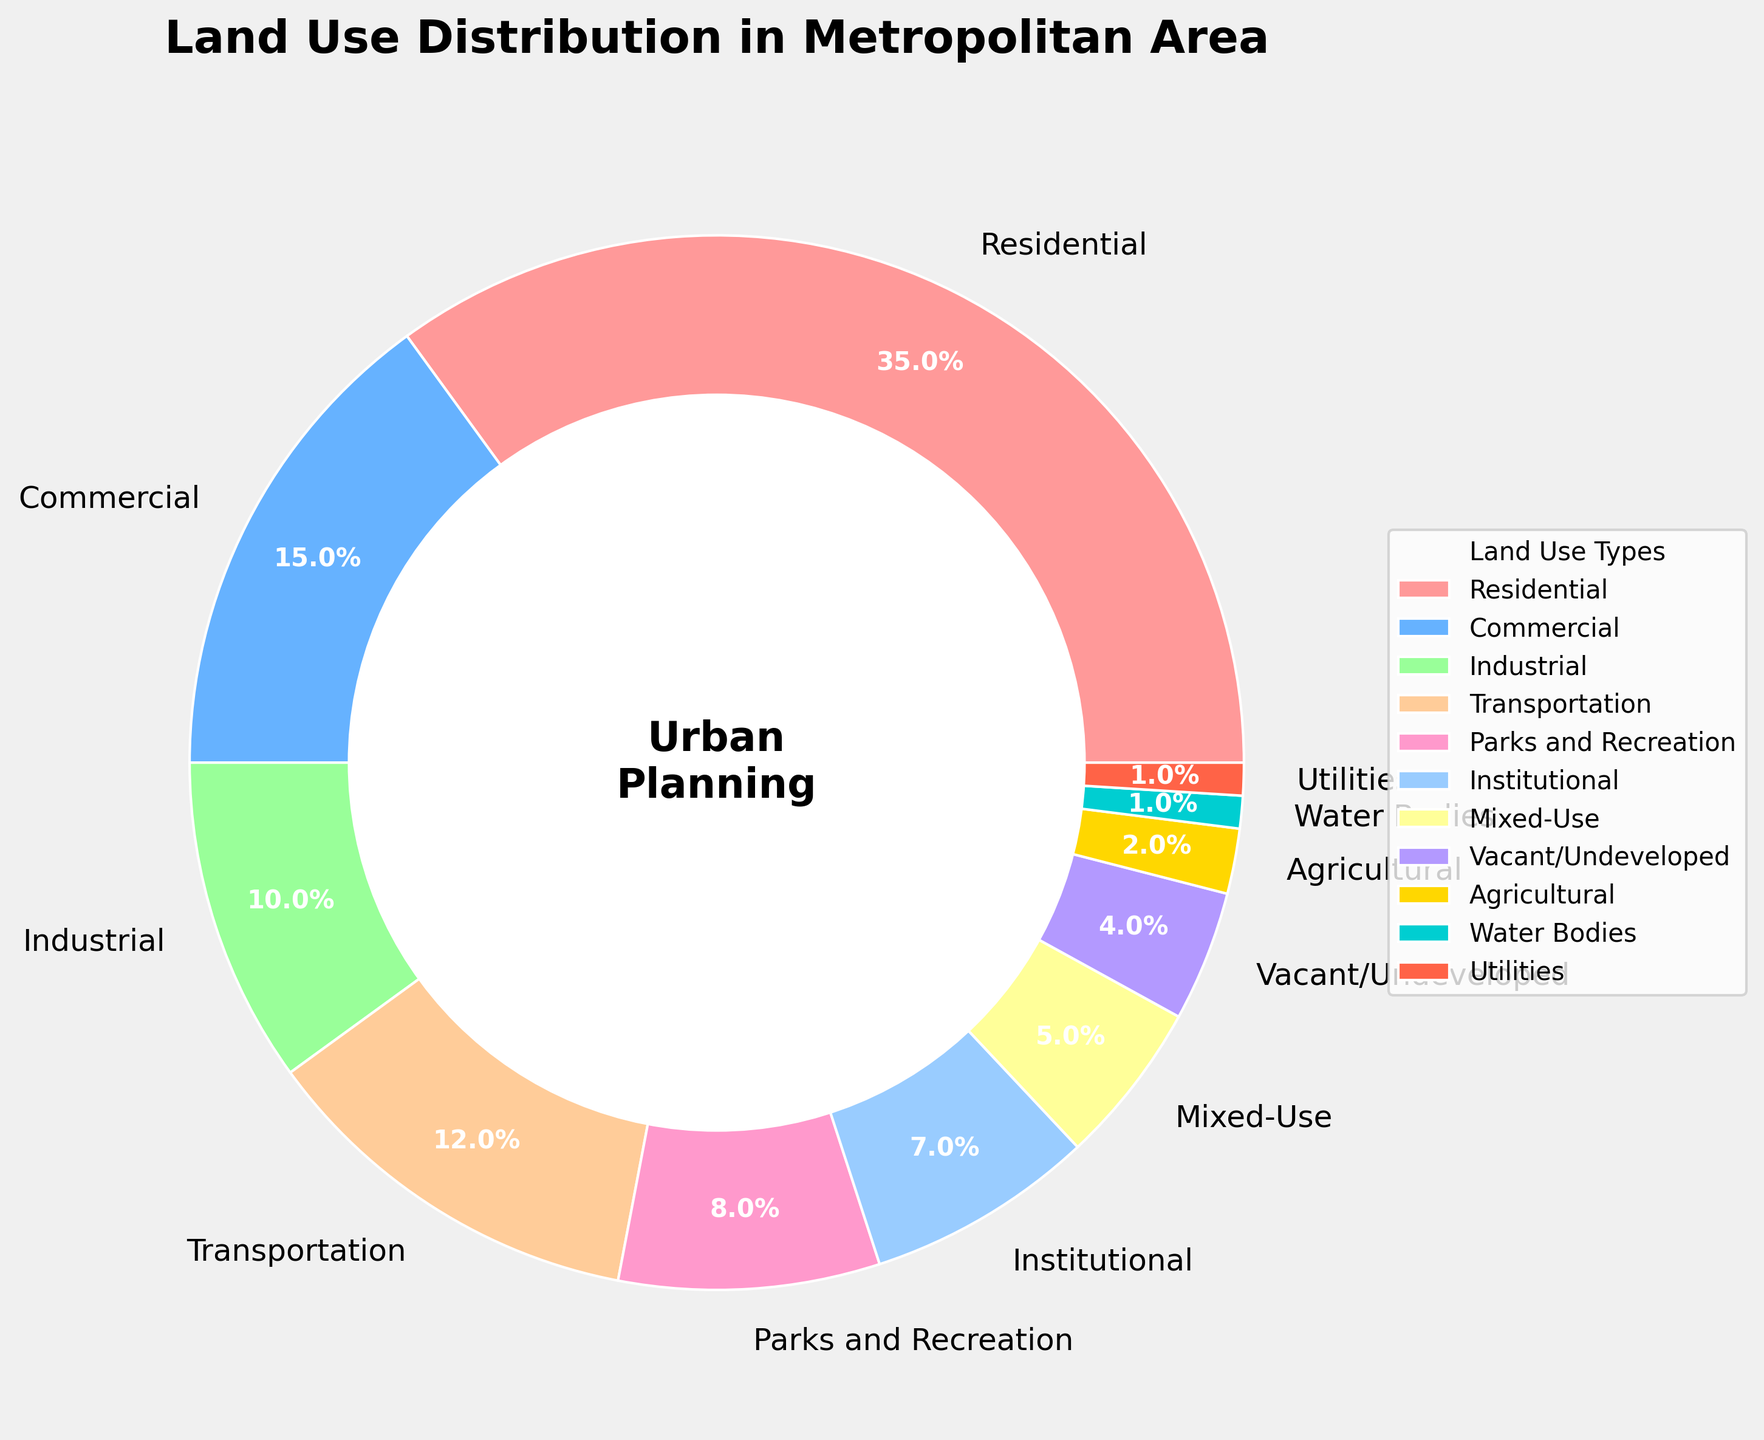What is the percentage of land used for Residential purposes? Locate the category labeled 'Residential' on the pie chart and read the corresponding percentage.
Answer: 35% Which two land use types together account for 20% of the land use? Identify the percentages for each category. Combining 'Institutional' (7%) and 'Parks and Recreation' (8%) and 'Utilities' (1%), you'll find that none of these combinations sum up to 20%. However, 'Transportation' (12%) and 'Vacant/Undeveloped' (4%) do sum up to 16%.
Answer: Transportation and Utilities What is the sum of the areas used for Commercial and Industrial purposes? Find the percentages labeled 'Commercial' and 'Industrial' and add them together: 15% (Commercial) + 10% (Industrial) = 25%.
Answer: 25% Which category occupies the smallest area in the metropolitan area? Identify the category with the smallest percentage on the pie chart. 'Utilities' and 'Water Bodies' both have the smallest percentage at 1%.
Answer: Utilities and Water Bodies How much more land is used for Residential purposes than for Industrial purposes? Subtract the percentage of land used for Industrial purposes from that used for Residential purposes: 35% (Residential) - 10% (Industrial) = 25%.
Answer: 25% What are the categories that occupy more land than Mixed-Use? Determine the percentage for 'Mixed-Use' (5%), then identify categories with a higher percentage: 'Residential' (35%), 'Commercial' (15%), 'Transportation' (12%), 'Industrial' (10%), and 'Parks and Recreation' (8%).
Answer: Residential, Commercial, Transportation, Industrial, Parks and Recreation What is the average percentage of land used for Residential, Commercial, and Industrial purposes? Add the percentages for 'Residential' (35%), 'Commercial' (15%), and 'Industrial' (10%) and then divide by the number of categories: (35% + 15% + 10%) / 3 = 20%.
Answer: 20% Which category is represented by the color red in the pie chart? Examine the colors associated with each category and identify 'Utilities', which is colored red.
Answer: Utilities Is there more land used for Parks and Recreation or Institutional purposes? Compare the percentages for 'Parks and Recreation' (8%) and 'Institutional' (7%): Parks and Recreation is more.
Answer: Parks and Recreation What percentage of the land is unused (Vacant/Undeveloped)? Locate the category labeled 'Vacant/Undeveloped' on the pie chart and note the percentage.
Answer: 4% 